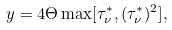Convert formula to latex. <formula><loc_0><loc_0><loc_500><loc_500>y = 4 \Theta \max [ \tau ^ { * } _ { \nu } , ( \tau ^ { * } _ { \nu } ) ^ { 2 } ] ,</formula> 